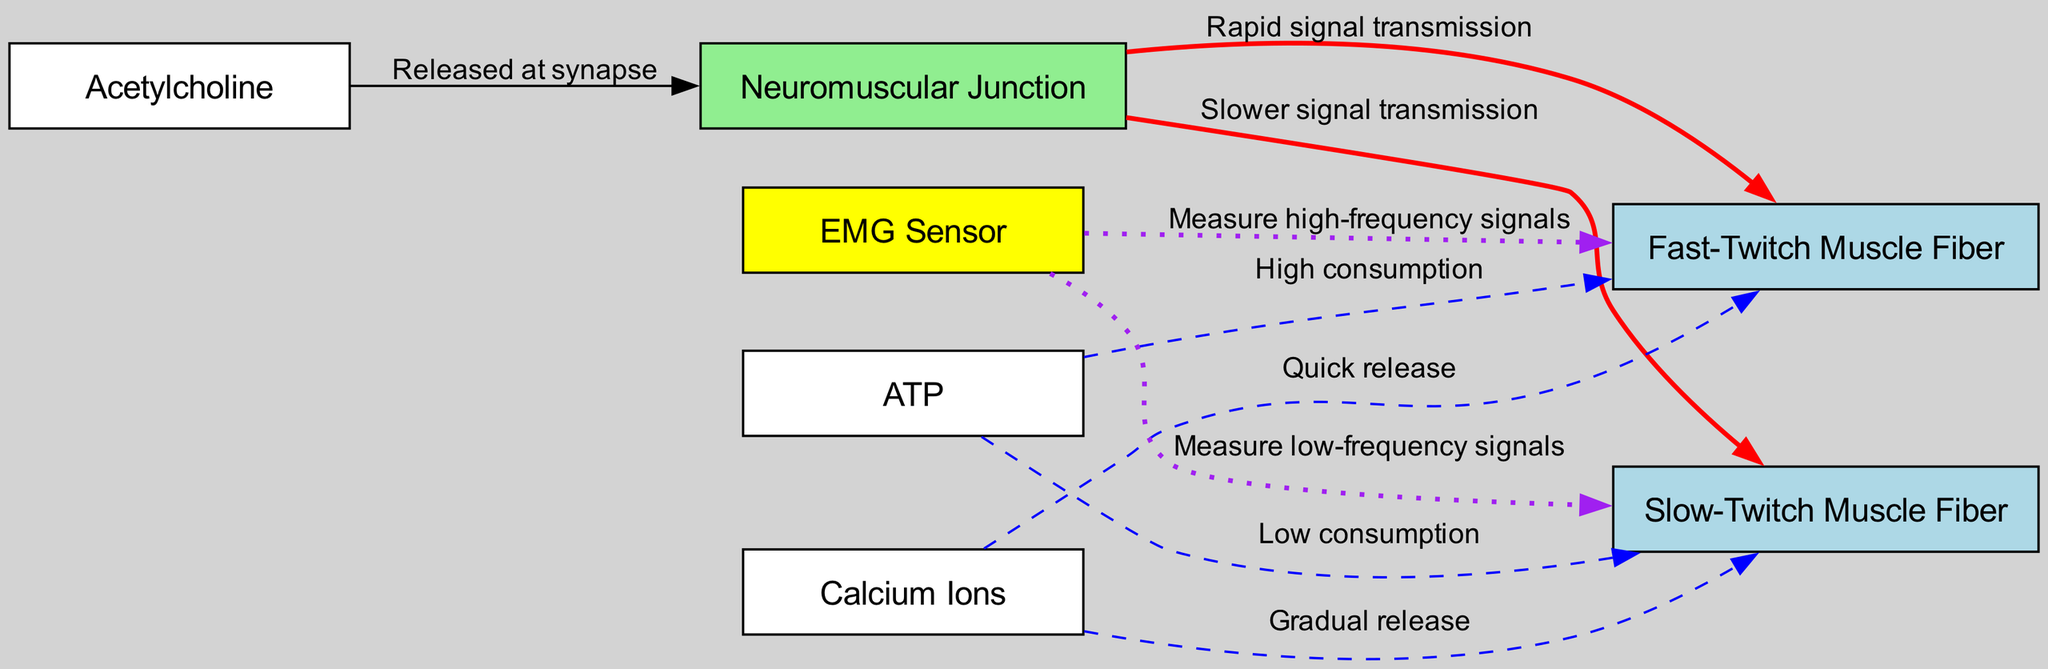What is the main function of the neuromuscular junction? The diagram shows the neuromuscular junction, which is the site where nerve impulses are transmitted to muscle fibers, thus allowing muscle contraction.
Answer: Transmitting signals How many types of muscle fibers are depicted in the diagram? There are two types of muscle fibers shown: fast-twitch and slow-twitch. Counting from the diagram, there are two distinct nodes representing these muscle fibers.
Answer: Two What is the relationship between acetylcholine and the neuromuscular junction? The diagram indicates that acetylcholine is released at the synapse, which connects to the neuromuscular junction, facilitating signal transmission.
Answer: Released at synapse Which muscle fiber type consumes ATP at a higher rate? The diagram shows that fast-twitch muscle fibers have high ATP consumption compared to slow-twitch fibers, which have low consumption.
Answer: Fast-Twitch Muscle Fiber What type of signals does the EMG sensor measure for fast-twitch muscle fibers? According to the diagram, the EMG sensor measures high-frequency signals for fast-twitch muscle fibers, indicating rapid muscle activity.
Answer: High-frequency signals What happens to calcium ions at the fast-twitch muscle fibers? The diagram reveals that calcium ions experience a quick release to facilitate immediate muscle contraction in fast-twitch fibers.
Answer: Quick release Which type of muscle fiber has a slower signal transmission? The diagram specifically illustrates that slow-twitch muscle fibers experience slower signal transmission compared to fast-twitch fibers.
Answer: Slow-Twitch Muscle Fiber What color represents the neuromuscular junction in the diagram? Referring to the diagram, the neuromuscular junction is represented in light green, which differentiates it from muscle fiber types.
Answer: Light green What is the visual indication of ATP consumption for slow-twitch fibers? The diagram shows a dashed line indicating a low consumption of ATP for slow-twitch muscle fibers, contrasting with the solid line for fast-twitch fibers.
Answer: Low consumption 